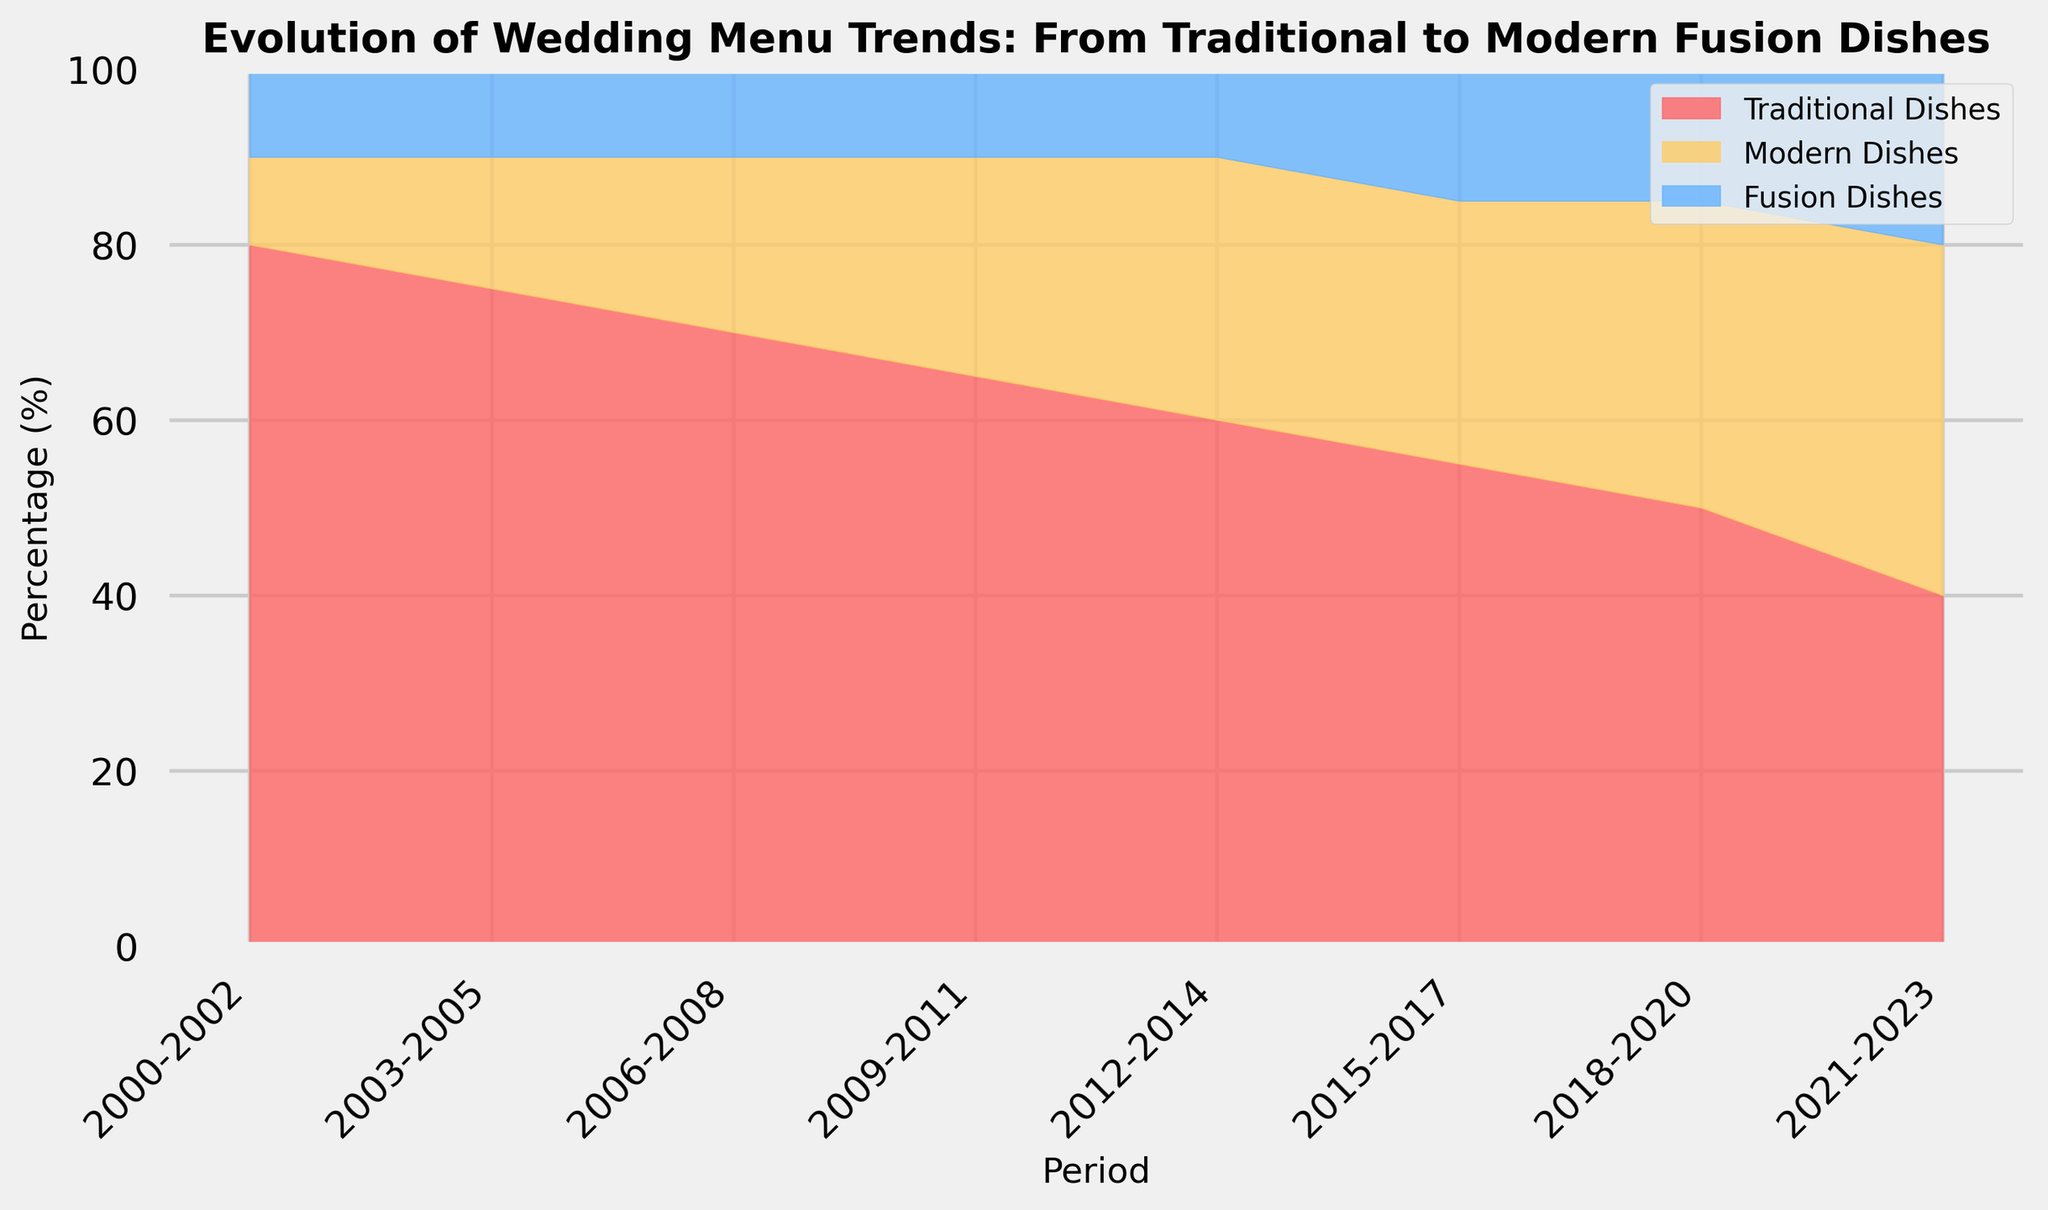What is the percentage of traditional dishes in the period 2000-2002? To determine this, look at the height of the area colored red at the start of the period 2000-2002. The figure shows that the red area covers 80% of the chart.
Answer: 80% Which period shows an equal percentage of traditional and modern dishes? Look for the period where the heights of areas colored red and yellow are the same. The period 2021-2023 shows 40% for both traditional and modern dishes, as indicated by the height of the red and yellow areas.
Answer: 2021-2023 How does the percentage of fusion dishes change from 2000-2002 to 2021-2023? By observing the blue area of the chart, we see that it remains constant at 10% from 2000-2002 through 2012-2014 and increases to 20% by 2021-2023.
Answer: Increased by 10% What is the trend for modern dishes from 2000-2002 to 2021-2023? Examining the yellow area shows an increase over the periods. Initially at 10% in 2000-2002, it increases gradually to 40% by 2021-2023.
Answer: Increasing trend Can you calculate the total percentage of traditional and modern dishes in 2015-2017? Sum the percentages of red and yellow areas for this period: 55% (traditional) + 30% (modern) = 85%.
Answer: 85% Which period has the highest percentage of fusion dishes? The highest blue area in the chart identifies the period with the highest percentage. This peak is observed in the period 2021-2023 at 20%.
Answer: 2021-2023 Is there a period where the modern dishes percentage remains constant? By examining the yellow area, it remains at 30% from 2012-2017; no other period shows a constant value.
Answer: 2012-2017 What is the combined percentage of modern and fusion dishes in 2009-2011? Add the percentages of yellow and blue areas for this period: 25% (modern) + 10% (fusion) = 35%.
Answer: 35% Which type of dish shows the most significant decline over the periods? Observing the trend, traditional dishes (red area) show a continuous and most significant decline from 80% in 2000-2002 to 40% in 2021-2023.
Answer: Traditional dishes What is the percentage difference between traditional and fusion dishes in 2018-2020? Calculate the difference between the heights of the red and blue areas: 50% (traditional) - 15% (fusion) = 35%.
Answer: 35% 